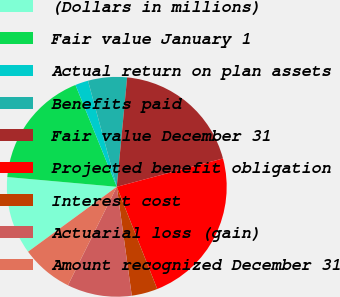Convert chart to OTSL. <chart><loc_0><loc_0><loc_500><loc_500><pie_chart><fcel>(Dollars in millions)<fcel>Fair value January 1<fcel>Actual return on plan assets<fcel>Benefits paid<fcel>Fair value December 31<fcel>Projected benefit obligation<fcel>Interest cost<fcel>Actuarial loss (gain)<fcel>Amount recognized December 31<nl><fcel>11.47%<fcel>17.45%<fcel>1.92%<fcel>5.72%<fcel>19.35%<fcel>23.15%<fcel>3.82%<fcel>9.51%<fcel>7.62%<nl></chart> 